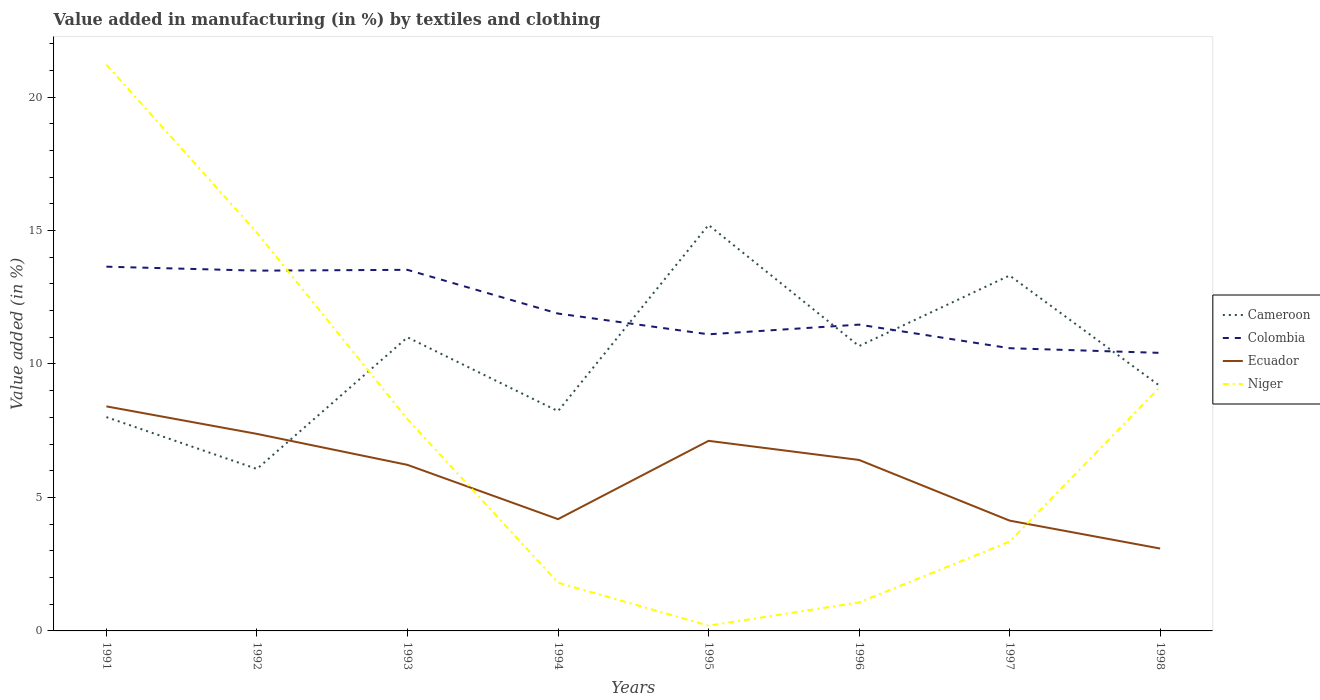How many different coloured lines are there?
Your answer should be compact. 4. Does the line corresponding to Colombia intersect with the line corresponding to Ecuador?
Offer a very short reply. No. Is the number of lines equal to the number of legend labels?
Make the answer very short. Yes. Across all years, what is the maximum percentage of value added in manufacturing by textiles and clothing in Colombia?
Offer a very short reply. 10.42. In which year was the percentage of value added in manufacturing by textiles and clothing in Cameroon maximum?
Offer a terse response. 1992. What is the total percentage of value added in manufacturing by textiles and clothing in Ecuador in the graph?
Your response must be concise. 2.01. What is the difference between the highest and the second highest percentage of value added in manufacturing by textiles and clothing in Ecuador?
Give a very brief answer. 5.33. Is the percentage of value added in manufacturing by textiles and clothing in Cameroon strictly greater than the percentage of value added in manufacturing by textiles and clothing in Niger over the years?
Make the answer very short. No. How many lines are there?
Ensure brevity in your answer.  4. How many years are there in the graph?
Your answer should be very brief. 8. Where does the legend appear in the graph?
Offer a terse response. Center right. What is the title of the graph?
Your response must be concise. Value added in manufacturing (in %) by textiles and clothing. What is the label or title of the Y-axis?
Give a very brief answer. Value added (in %). What is the Value added (in %) in Cameroon in 1991?
Keep it short and to the point. 8.01. What is the Value added (in %) in Colombia in 1991?
Your answer should be compact. 13.64. What is the Value added (in %) of Ecuador in 1991?
Ensure brevity in your answer.  8.41. What is the Value added (in %) in Niger in 1991?
Provide a short and direct response. 21.21. What is the Value added (in %) of Cameroon in 1992?
Offer a very short reply. 6.07. What is the Value added (in %) of Colombia in 1992?
Keep it short and to the point. 13.5. What is the Value added (in %) of Ecuador in 1992?
Offer a terse response. 7.38. What is the Value added (in %) of Niger in 1992?
Provide a succinct answer. 14.92. What is the Value added (in %) of Cameroon in 1993?
Your response must be concise. 11. What is the Value added (in %) in Colombia in 1993?
Your answer should be compact. 13.53. What is the Value added (in %) of Ecuador in 1993?
Your response must be concise. 6.22. What is the Value added (in %) in Niger in 1993?
Provide a succinct answer. 7.93. What is the Value added (in %) in Cameroon in 1994?
Provide a short and direct response. 8.23. What is the Value added (in %) in Colombia in 1994?
Keep it short and to the point. 11.89. What is the Value added (in %) of Ecuador in 1994?
Your response must be concise. 4.19. What is the Value added (in %) of Niger in 1994?
Provide a succinct answer. 1.81. What is the Value added (in %) in Cameroon in 1995?
Give a very brief answer. 15.21. What is the Value added (in %) of Colombia in 1995?
Keep it short and to the point. 11.11. What is the Value added (in %) of Ecuador in 1995?
Give a very brief answer. 7.12. What is the Value added (in %) in Niger in 1995?
Ensure brevity in your answer.  0.2. What is the Value added (in %) of Cameroon in 1996?
Provide a succinct answer. 10.67. What is the Value added (in %) in Colombia in 1996?
Your answer should be compact. 11.47. What is the Value added (in %) of Ecuador in 1996?
Offer a very short reply. 6.4. What is the Value added (in %) in Niger in 1996?
Offer a terse response. 1.07. What is the Value added (in %) of Cameroon in 1997?
Make the answer very short. 13.31. What is the Value added (in %) of Colombia in 1997?
Ensure brevity in your answer.  10.59. What is the Value added (in %) of Ecuador in 1997?
Your answer should be very brief. 4.13. What is the Value added (in %) of Niger in 1997?
Your answer should be very brief. 3.35. What is the Value added (in %) of Cameroon in 1998?
Provide a succinct answer. 9.17. What is the Value added (in %) in Colombia in 1998?
Provide a short and direct response. 10.42. What is the Value added (in %) in Ecuador in 1998?
Ensure brevity in your answer.  3.09. What is the Value added (in %) of Niger in 1998?
Your response must be concise. 9.14. Across all years, what is the maximum Value added (in %) in Cameroon?
Make the answer very short. 15.21. Across all years, what is the maximum Value added (in %) of Colombia?
Your answer should be compact. 13.64. Across all years, what is the maximum Value added (in %) of Ecuador?
Offer a very short reply. 8.41. Across all years, what is the maximum Value added (in %) of Niger?
Give a very brief answer. 21.21. Across all years, what is the minimum Value added (in %) in Cameroon?
Give a very brief answer. 6.07. Across all years, what is the minimum Value added (in %) of Colombia?
Give a very brief answer. 10.42. Across all years, what is the minimum Value added (in %) of Ecuador?
Offer a terse response. 3.09. Across all years, what is the minimum Value added (in %) of Niger?
Keep it short and to the point. 0.2. What is the total Value added (in %) in Cameroon in the graph?
Offer a very short reply. 81.67. What is the total Value added (in %) in Colombia in the graph?
Make the answer very short. 96.15. What is the total Value added (in %) in Ecuador in the graph?
Make the answer very short. 46.94. What is the total Value added (in %) of Niger in the graph?
Ensure brevity in your answer.  59.63. What is the difference between the Value added (in %) of Cameroon in 1991 and that in 1992?
Your response must be concise. 1.94. What is the difference between the Value added (in %) in Colombia in 1991 and that in 1992?
Provide a short and direct response. 0.15. What is the difference between the Value added (in %) in Ecuador in 1991 and that in 1992?
Offer a terse response. 1.03. What is the difference between the Value added (in %) of Niger in 1991 and that in 1992?
Provide a short and direct response. 6.3. What is the difference between the Value added (in %) of Cameroon in 1991 and that in 1993?
Your answer should be very brief. -2.99. What is the difference between the Value added (in %) in Colombia in 1991 and that in 1993?
Offer a very short reply. 0.12. What is the difference between the Value added (in %) of Ecuador in 1991 and that in 1993?
Keep it short and to the point. 2.19. What is the difference between the Value added (in %) in Niger in 1991 and that in 1993?
Make the answer very short. 13.28. What is the difference between the Value added (in %) in Cameroon in 1991 and that in 1994?
Ensure brevity in your answer.  -0.22. What is the difference between the Value added (in %) in Colombia in 1991 and that in 1994?
Make the answer very short. 1.76. What is the difference between the Value added (in %) in Ecuador in 1991 and that in 1994?
Keep it short and to the point. 4.22. What is the difference between the Value added (in %) in Niger in 1991 and that in 1994?
Your response must be concise. 19.4. What is the difference between the Value added (in %) of Cameroon in 1991 and that in 1995?
Make the answer very short. -7.2. What is the difference between the Value added (in %) of Colombia in 1991 and that in 1995?
Ensure brevity in your answer.  2.53. What is the difference between the Value added (in %) of Ecuador in 1991 and that in 1995?
Make the answer very short. 1.29. What is the difference between the Value added (in %) of Niger in 1991 and that in 1995?
Your answer should be compact. 21.02. What is the difference between the Value added (in %) in Cameroon in 1991 and that in 1996?
Provide a succinct answer. -2.66. What is the difference between the Value added (in %) of Colombia in 1991 and that in 1996?
Make the answer very short. 2.17. What is the difference between the Value added (in %) of Ecuador in 1991 and that in 1996?
Keep it short and to the point. 2.01. What is the difference between the Value added (in %) in Niger in 1991 and that in 1996?
Keep it short and to the point. 20.15. What is the difference between the Value added (in %) in Cameroon in 1991 and that in 1997?
Offer a very short reply. -5.3. What is the difference between the Value added (in %) of Colombia in 1991 and that in 1997?
Offer a very short reply. 3.05. What is the difference between the Value added (in %) in Ecuador in 1991 and that in 1997?
Give a very brief answer. 4.28. What is the difference between the Value added (in %) of Niger in 1991 and that in 1997?
Keep it short and to the point. 17.87. What is the difference between the Value added (in %) in Cameroon in 1991 and that in 1998?
Offer a very short reply. -1.16. What is the difference between the Value added (in %) of Colombia in 1991 and that in 1998?
Your answer should be compact. 3.23. What is the difference between the Value added (in %) in Ecuador in 1991 and that in 1998?
Give a very brief answer. 5.33. What is the difference between the Value added (in %) of Niger in 1991 and that in 1998?
Give a very brief answer. 12.07. What is the difference between the Value added (in %) in Cameroon in 1992 and that in 1993?
Ensure brevity in your answer.  -4.93. What is the difference between the Value added (in %) in Colombia in 1992 and that in 1993?
Your answer should be very brief. -0.03. What is the difference between the Value added (in %) of Ecuador in 1992 and that in 1993?
Offer a terse response. 1.16. What is the difference between the Value added (in %) in Niger in 1992 and that in 1993?
Offer a terse response. 6.99. What is the difference between the Value added (in %) of Cameroon in 1992 and that in 1994?
Offer a very short reply. -2.17. What is the difference between the Value added (in %) of Colombia in 1992 and that in 1994?
Your answer should be compact. 1.61. What is the difference between the Value added (in %) of Ecuador in 1992 and that in 1994?
Offer a terse response. 3.19. What is the difference between the Value added (in %) in Niger in 1992 and that in 1994?
Offer a very short reply. 13.11. What is the difference between the Value added (in %) of Cameroon in 1992 and that in 1995?
Provide a short and direct response. -9.14. What is the difference between the Value added (in %) of Colombia in 1992 and that in 1995?
Provide a short and direct response. 2.38. What is the difference between the Value added (in %) of Ecuador in 1992 and that in 1995?
Give a very brief answer. 0.26. What is the difference between the Value added (in %) of Niger in 1992 and that in 1995?
Your answer should be compact. 14.72. What is the difference between the Value added (in %) of Cameroon in 1992 and that in 1996?
Offer a very short reply. -4.6. What is the difference between the Value added (in %) of Colombia in 1992 and that in 1996?
Give a very brief answer. 2.02. What is the difference between the Value added (in %) of Ecuador in 1992 and that in 1996?
Provide a succinct answer. 0.98. What is the difference between the Value added (in %) of Niger in 1992 and that in 1996?
Give a very brief answer. 13.85. What is the difference between the Value added (in %) of Cameroon in 1992 and that in 1997?
Your answer should be very brief. -7.25. What is the difference between the Value added (in %) in Colombia in 1992 and that in 1997?
Ensure brevity in your answer.  2.91. What is the difference between the Value added (in %) in Ecuador in 1992 and that in 1997?
Make the answer very short. 3.25. What is the difference between the Value added (in %) of Niger in 1992 and that in 1997?
Give a very brief answer. 11.57. What is the difference between the Value added (in %) of Cameroon in 1992 and that in 1998?
Ensure brevity in your answer.  -3.1. What is the difference between the Value added (in %) of Colombia in 1992 and that in 1998?
Your answer should be compact. 3.08. What is the difference between the Value added (in %) in Ecuador in 1992 and that in 1998?
Your answer should be compact. 4.29. What is the difference between the Value added (in %) of Niger in 1992 and that in 1998?
Provide a short and direct response. 5.77. What is the difference between the Value added (in %) of Cameroon in 1993 and that in 1994?
Keep it short and to the point. 2.77. What is the difference between the Value added (in %) in Colombia in 1993 and that in 1994?
Your response must be concise. 1.64. What is the difference between the Value added (in %) of Ecuador in 1993 and that in 1994?
Provide a short and direct response. 2.03. What is the difference between the Value added (in %) in Niger in 1993 and that in 1994?
Your answer should be compact. 6.12. What is the difference between the Value added (in %) of Cameroon in 1993 and that in 1995?
Make the answer very short. -4.21. What is the difference between the Value added (in %) in Colombia in 1993 and that in 1995?
Make the answer very short. 2.42. What is the difference between the Value added (in %) of Ecuador in 1993 and that in 1995?
Keep it short and to the point. -0.9. What is the difference between the Value added (in %) of Niger in 1993 and that in 1995?
Keep it short and to the point. 7.73. What is the difference between the Value added (in %) in Cameroon in 1993 and that in 1996?
Offer a terse response. 0.33. What is the difference between the Value added (in %) in Colombia in 1993 and that in 1996?
Give a very brief answer. 2.05. What is the difference between the Value added (in %) in Ecuador in 1993 and that in 1996?
Give a very brief answer. -0.18. What is the difference between the Value added (in %) in Niger in 1993 and that in 1996?
Provide a short and direct response. 6.86. What is the difference between the Value added (in %) of Cameroon in 1993 and that in 1997?
Ensure brevity in your answer.  -2.32. What is the difference between the Value added (in %) in Colombia in 1993 and that in 1997?
Offer a very short reply. 2.94. What is the difference between the Value added (in %) in Ecuador in 1993 and that in 1997?
Offer a terse response. 2.09. What is the difference between the Value added (in %) in Niger in 1993 and that in 1997?
Provide a short and direct response. 4.58. What is the difference between the Value added (in %) in Cameroon in 1993 and that in 1998?
Provide a short and direct response. 1.83. What is the difference between the Value added (in %) of Colombia in 1993 and that in 1998?
Your response must be concise. 3.11. What is the difference between the Value added (in %) in Ecuador in 1993 and that in 1998?
Keep it short and to the point. 3.13. What is the difference between the Value added (in %) of Niger in 1993 and that in 1998?
Keep it short and to the point. -1.21. What is the difference between the Value added (in %) of Cameroon in 1994 and that in 1995?
Offer a terse response. -6.97. What is the difference between the Value added (in %) of Colombia in 1994 and that in 1995?
Your answer should be very brief. 0.78. What is the difference between the Value added (in %) of Ecuador in 1994 and that in 1995?
Provide a succinct answer. -2.93. What is the difference between the Value added (in %) of Niger in 1994 and that in 1995?
Provide a succinct answer. 1.61. What is the difference between the Value added (in %) in Cameroon in 1994 and that in 1996?
Make the answer very short. -2.44. What is the difference between the Value added (in %) of Colombia in 1994 and that in 1996?
Your response must be concise. 0.41. What is the difference between the Value added (in %) of Ecuador in 1994 and that in 1996?
Give a very brief answer. -2.22. What is the difference between the Value added (in %) of Niger in 1994 and that in 1996?
Provide a succinct answer. 0.74. What is the difference between the Value added (in %) in Cameroon in 1994 and that in 1997?
Your answer should be very brief. -5.08. What is the difference between the Value added (in %) of Colombia in 1994 and that in 1997?
Offer a very short reply. 1.3. What is the difference between the Value added (in %) in Ecuador in 1994 and that in 1997?
Keep it short and to the point. 0.06. What is the difference between the Value added (in %) of Niger in 1994 and that in 1997?
Keep it short and to the point. -1.54. What is the difference between the Value added (in %) in Cameroon in 1994 and that in 1998?
Provide a succinct answer. -0.94. What is the difference between the Value added (in %) of Colombia in 1994 and that in 1998?
Your answer should be very brief. 1.47. What is the difference between the Value added (in %) of Ecuador in 1994 and that in 1998?
Keep it short and to the point. 1.1. What is the difference between the Value added (in %) of Niger in 1994 and that in 1998?
Your answer should be compact. -7.33. What is the difference between the Value added (in %) of Cameroon in 1995 and that in 1996?
Provide a succinct answer. 4.54. What is the difference between the Value added (in %) in Colombia in 1995 and that in 1996?
Provide a short and direct response. -0.36. What is the difference between the Value added (in %) in Ecuador in 1995 and that in 1996?
Offer a terse response. 0.72. What is the difference between the Value added (in %) in Niger in 1995 and that in 1996?
Make the answer very short. -0.87. What is the difference between the Value added (in %) of Cameroon in 1995 and that in 1997?
Make the answer very short. 1.89. What is the difference between the Value added (in %) of Colombia in 1995 and that in 1997?
Provide a short and direct response. 0.52. What is the difference between the Value added (in %) of Ecuador in 1995 and that in 1997?
Give a very brief answer. 2.99. What is the difference between the Value added (in %) in Niger in 1995 and that in 1997?
Offer a terse response. -3.15. What is the difference between the Value added (in %) in Cameroon in 1995 and that in 1998?
Your answer should be very brief. 6.04. What is the difference between the Value added (in %) of Colombia in 1995 and that in 1998?
Your response must be concise. 0.7. What is the difference between the Value added (in %) of Ecuador in 1995 and that in 1998?
Your answer should be compact. 4.03. What is the difference between the Value added (in %) of Niger in 1995 and that in 1998?
Your answer should be very brief. -8.95. What is the difference between the Value added (in %) of Cameroon in 1996 and that in 1997?
Provide a succinct answer. -2.64. What is the difference between the Value added (in %) of Colombia in 1996 and that in 1997?
Your answer should be compact. 0.88. What is the difference between the Value added (in %) in Ecuador in 1996 and that in 1997?
Offer a very short reply. 2.27. What is the difference between the Value added (in %) in Niger in 1996 and that in 1997?
Provide a short and direct response. -2.28. What is the difference between the Value added (in %) of Cameroon in 1996 and that in 1998?
Your response must be concise. 1.5. What is the difference between the Value added (in %) of Colombia in 1996 and that in 1998?
Your answer should be compact. 1.06. What is the difference between the Value added (in %) of Ecuador in 1996 and that in 1998?
Your response must be concise. 3.32. What is the difference between the Value added (in %) in Niger in 1996 and that in 1998?
Make the answer very short. -8.08. What is the difference between the Value added (in %) in Cameroon in 1997 and that in 1998?
Ensure brevity in your answer.  4.14. What is the difference between the Value added (in %) of Colombia in 1997 and that in 1998?
Provide a succinct answer. 0.18. What is the difference between the Value added (in %) of Ecuador in 1997 and that in 1998?
Ensure brevity in your answer.  1.05. What is the difference between the Value added (in %) in Niger in 1997 and that in 1998?
Give a very brief answer. -5.8. What is the difference between the Value added (in %) of Cameroon in 1991 and the Value added (in %) of Colombia in 1992?
Provide a short and direct response. -5.49. What is the difference between the Value added (in %) in Cameroon in 1991 and the Value added (in %) in Ecuador in 1992?
Keep it short and to the point. 0.63. What is the difference between the Value added (in %) of Cameroon in 1991 and the Value added (in %) of Niger in 1992?
Provide a succinct answer. -6.91. What is the difference between the Value added (in %) of Colombia in 1991 and the Value added (in %) of Ecuador in 1992?
Your answer should be very brief. 6.26. What is the difference between the Value added (in %) in Colombia in 1991 and the Value added (in %) in Niger in 1992?
Offer a very short reply. -1.27. What is the difference between the Value added (in %) in Ecuador in 1991 and the Value added (in %) in Niger in 1992?
Your answer should be very brief. -6.51. What is the difference between the Value added (in %) of Cameroon in 1991 and the Value added (in %) of Colombia in 1993?
Ensure brevity in your answer.  -5.52. What is the difference between the Value added (in %) of Cameroon in 1991 and the Value added (in %) of Ecuador in 1993?
Your response must be concise. 1.79. What is the difference between the Value added (in %) of Cameroon in 1991 and the Value added (in %) of Niger in 1993?
Give a very brief answer. 0.08. What is the difference between the Value added (in %) in Colombia in 1991 and the Value added (in %) in Ecuador in 1993?
Make the answer very short. 7.42. What is the difference between the Value added (in %) in Colombia in 1991 and the Value added (in %) in Niger in 1993?
Offer a terse response. 5.71. What is the difference between the Value added (in %) in Ecuador in 1991 and the Value added (in %) in Niger in 1993?
Make the answer very short. 0.48. What is the difference between the Value added (in %) in Cameroon in 1991 and the Value added (in %) in Colombia in 1994?
Give a very brief answer. -3.88. What is the difference between the Value added (in %) of Cameroon in 1991 and the Value added (in %) of Ecuador in 1994?
Give a very brief answer. 3.82. What is the difference between the Value added (in %) of Cameroon in 1991 and the Value added (in %) of Niger in 1994?
Offer a very short reply. 6.2. What is the difference between the Value added (in %) in Colombia in 1991 and the Value added (in %) in Ecuador in 1994?
Offer a very short reply. 9.46. What is the difference between the Value added (in %) of Colombia in 1991 and the Value added (in %) of Niger in 1994?
Your answer should be very brief. 11.84. What is the difference between the Value added (in %) in Ecuador in 1991 and the Value added (in %) in Niger in 1994?
Provide a short and direct response. 6.6. What is the difference between the Value added (in %) in Cameroon in 1991 and the Value added (in %) in Colombia in 1995?
Your answer should be very brief. -3.1. What is the difference between the Value added (in %) of Cameroon in 1991 and the Value added (in %) of Ecuador in 1995?
Provide a succinct answer. 0.89. What is the difference between the Value added (in %) in Cameroon in 1991 and the Value added (in %) in Niger in 1995?
Give a very brief answer. 7.81. What is the difference between the Value added (in %) in Colombia in 1991 and the Value added (in %) in Ecuador in 1995?
Offer a terse response. 6.52. What is the difference between the Value added (in %) in Colombia in 1991 and the Value added (in %) in Niger in 1995?
Your response must be concise. 13.45. What is the difference between the Value added (in %) in Ecuador in 1991 and the Value added (in %) in Niger in 1995?
Ensure brevity in your answer.  8.21. What is the difference between the Value added (in %) of Cameroon in 1991 and the Value added (in %) of Colombia in 1996?
Your answer should be compact. -3.46. What is the difference between the Value added (in %) in Cameroon in 1991 and the Value added (in %) in Ecuador in 1996?
Provide a succinct answer. 1.6. What is the difference between the Value added (in %) in Cameroon in 1991 and the Value added (in %) in Niger in 1996?
Your answer should be compact. 6.94. What is the difference between the Value added (in %) of Colombia in 1991 and the Value added (in %) of Ecuador in 1996?
Ensure brevity in your answer.  7.24. What is the difference between the Value added (in %) of Colombia in 1991 and the Value added (in %) of Niger in 1996?
Keep it short and to the point. 12.58. What is the difference between the Value added (in %) of Ecuador in 1991 and the Value added (in %) of Niger in 1996?
Offer a very short reply. 7.34. What is the difference between the Value added (in %) in Cameroon in 1991 and the Value added (in %) in Colombia in 1997?
Your answer should be compact. -2.58. What is the difference between the Value added (in %) of Cameroon in 1991 and the Value added (in %) of Ecuador in 1997?
Provide a short and direct response. 3.88. What is the difference between the Value added (in %) in Cameroon in 1991 and the Value added (in %) in Niger in 1997?
Your answer should be compact. 4.66. What is the difference between the Value added (in %) in Colombia in 1991 and the Value added (in %) in Ecuador in 1997?
Make the answer very short. 9.51. What is the difference between the Value added (in %) in Colombia in 1991 and the Value added (in %) in Niger in 1997?
Make the answer very short. 10.3. What is the difference between the Value added (in %) in Ecuador in 1991 and the Value added (in %) in Niger in 1997?
Give a very brief answer. 5.06. What is the difference between the Value added (in %) of Cameroon in 1991 and the Value added (in %) of Colombia in 1998?
Your answer should be very brief. -2.41. What is the difference between the Value added (in %) in Cameroon in 1991 and the Value added (in %) in Ecuador in 1998?
Give a very brief answer. 4.92. What is the difference between the Value added (in %) of Cameroon in 1991 and the Value added (in %) of Niger in 1998?
Your response must be concise. -1.13. What is the difference between the Value added (in %) in Colombia in 1991 and the Value added (in %) in Ecuador in 1998?
Offer a very short reply. 10.56. What is the difference between the Value added (in %) in Colombia in 1991 and the Value added (in %) in Niger in 1998?
Your answer should be very brief. 4.5. What is the difference between the Value added (in %) of Ecuador in 1991 and the Value added (in %) of Niger in 1998?
Make the answer very short. -0.73. What is the difference between the Value added (in %) of Cameroon in 1992 and the Value added (in %) of Colombia in 1993?
Your response must be concise. -7.46. What is the difference between the Value added (in %) in Cameroon in 1992 and the Value added (in %) in Ecuador in 1993?
Make the answer very short. -0.15. What is the difference between the Value added (in %) in Cameroon in 1992 and the Value added (in %) in Niger in 1993?
Your answer should be compact. -1.86. What is the difference between the Value added (in %) of Colombia in 1992 and the Value added (in %) of Ecuador in 1993?
Offer a terse response. 7.28. What is the difference between the Value added (in %) in Colombia in 1992 and the Value added (in %) in Niger in 1993?
Give a very brief answer. 5.56. What is the difference between the Value added (in %) in Ecuador in 1992 and the Value added (in %) in Niger in 1993?
Provide a succinct answer. -0.55. What is the difference between the Value added (in %) in Cameroon in 1992 and the Value added (in %) in Colombia in 1994?
Ensure brevity in your answer.  -5.82. What is the difference between the Value added (in %) of Cameroon in 1992 and the Value added (in %) of Ecuador in 1994?
Offer a terse response. 1.88. What is the difference between the Value added (in %) of Cameroon in 1992 and the Value added (in %) of Niger in 1994?
Keep it short and to the point. 4.26. What is the difference between the Value added (in %) of Colombia in 1992 and the Value added (in %) of Ecuador in 1994?
Your answer should be very brief. 9.31. What is the difference between the Value added (in %) in Colombia in 1992 and the Value added (in %) in Niger in 1994?
Ensure brevity in your answer.  11.69. What is the difference between the Value added (in %) in Ecuador in 1992 and the Value added (in %) in Niger in 1994?
Offer a terse response. 5.57. What is the difference between the Value added (in %) of Cameroon in 1992 and the Value added (in %) of Colombia in 1995?
Make the answer very short. -5.04. What is the difference between the Value added (in %) of Cameroon in 1992 and the Value added (in %) of Ecuador in 1995?
Your answer should be very brief. -1.05. What is the difference between the Value added (in %) of Cameroon in 1992 and the Value added (in %) of Niger in 1995?
Offer a very short reply. 5.87. What is the difference between the Value added (in %) of Colombia in 1992 and the Value added (in %) of Ecuador in 1995?
Provide a short and direct response. 6.38. What is the difference between the Value added (in %) of Colombia in 1992 and the Value added (in %) of Niger in 1995?
Your answer should be very brief. 13.3. What is the difference between the Value added (in %) of Ecuador in 1992 and the Value added (in %) of Niger in 1995?
Your response must be concise. 7.18. What is the difference between the Value added (in %) in Cameroon in 1992 and the Value added (in %) in Colombia in 1996?
Your answer should be very brief. -5.41. What is the difference between the Value added (in %) in Cameroon in 1992 and the Value added (in %) in Ecuador in 1996?
Your answer should be very brief. -0.34. What is the difference between the Value added (in %) of Cameroon in 1992 and the Value added (in %) of Niger in 1996?
Ensure brevity in your answer.  5. What is the difference between the Value added (in %) in Colombia in 1992 and the Value added (in %) in Ecuador in 1996?
Make the answer very short. 7.09. What is the difference between the Value added (in %) in Colombia in 1992 and the Value added (in %) in Niger in 1996?
Provide a succinct answer. 12.43. What is the difference between the Value added (in %) of Ecuador in 1992 and the Value added (in %) of Niger in 1996?
Ensure brevity in your answer.  6.31. What is the difference between the Value added (in %) in Cameroon in 1992 and the Value added (in %) in Colombia in 1997?
Offer a terse response. -4.52. What is the difference between the Value added (in %) in Cameroon in 1992 and the Value added (in %) in Ecuador in 1997?
Your answer should be very brief. 1.93. What is the difference between the Value added (in %) in Cameroon in 1992 and the Value added (in %) in Niger in 1997?
Offer a terse response. 2.72. What is the difference between the Value added (in %) of Colombia in 1992 and the Value added (in %) of Ecuador in 1997?
Ensure brevity in your answer.  9.36. What is the difference between the Value added (in %) of Colombia in 1992 and the Value added (in %) of Niger in 1997?
Keep it short and to the point. 10.15. What is the difference between the Value added (in %) of Ecuador in 1992 and the Value added (in %) of Niger in 1997?
Provide a succinct answer. 4.03. What is the difference between the Value added (in %) of Cameroon in 1992 and the Value added (in %) of Colombia in 1998?
Ensure brevity in your answer.  -4.35. What is the difference between the Value added (in %) in Cameroon in 1992 and the Value added (in %) in Ecuador in 1998?
Your answer should be compact. 2.98. What is the difference between the Value added (in %) in Cameroon in 1992 and the Value added (in %) in Niger in 1998?
Your answer should be very brief. -3.08. What is the difference between the Value added (in %) of Colombia in 1992 and the Value added (in %) of Ecuador in 1998?
Your answer should be compact. 10.41. What is the difference between the Value added (in %) in Colombia in 1992 and the Value added (in %) in Niger in 1998?
Provide a succinct answer. 4.35. What is the difference between the Value added (in %) in Ecuador in 1992 and the Value added (in %) in Niger in 1998?
Make the answer very short. -1.76. What is the difference between the Value added (in %) of Cameroon in 1993 and the Value added (in %) of Colombia in 1994?
Offer a terse response. -0.89. What is the difference between the Value added (in %) in Cameroon in 1993 and the Value added (in %) in Ecuador in 1994?
Give a very brief answer. 6.81. What is the difference between the Value added (in %) in Cameroon in 1993 and the Value added (in %) in Niger in 1994?
Keep it short and to the point. 9.19. What is the difference between the Value added (in %) of Colombia in 1993 and the Value added (in %) of Ecuador in 1994?
Provide a succinct answer. 9.34. What is the difference between the Value added (in %) of Colombia in 1993 and the Value added (in %) of Niger in 1994?
Keep it short and to the point. 11.72. What is the difference between the Value added (in %) of Ecuador in 1993 and the Value added (in %) of Niger in 1994?
Ensure brevity in your answer.  4.41. What is the difference between the Value added (in %) in Cameroon in 1993 and the Value added (in %) in Colombia in 1995?
Provide a short and direct response. -0.11. What is the difference between the Value added (in %) in Cameroon in 1993 and the Value added (in %) in Ecuador in 1995?
Your response must be concise. 3.88. What is the difference between the Value added (in %) of Cameroon in 1993 and the Value added (in %) of Niger in 1995?
Keep it short and to the point. 10.8. What is the difference between the Value added (in %) of Colombia in 1993 and the Value added (in %) of Ecuador in 1995?
Ensure brevity in your answer.  6.41. What is the difference between the Value added (in %) in Colombia in 1993 and the Value added (in %) in Niger in 1995?
Offer a terse response. 13.33. What is the difference between the Value added (in %) of Ecuador in 1993 and the Value added (in %) of Niger in 1995?
Your response must be concise. 6.02. What is the difference between the Value added (in %) in Cameroon in 1993 and the Value added (in %) in Colombia in 1996?
Give a very brief answer. -0.48. What is the difference between the Value added (in %) in Cameroon in 1993 and the Value added (in %) in Ecuador in 1996?
Make the answer very short. 4.59. What is the difference between the Value added (in %) in Cameroon in 1993 and the Value added (in %) in Niger in 1996?
Give a very brief answer. 9.93. What is the difference between the Value added (in %) in Colombia in 1993 and the Value added (in %) in Ecuador in 1996?
Ensure brevity in your answer.  7.12. What is the difference between the Value added (in %) in Colombia in 1993 and the Value added (in %) in Niger in 1996?
Provide a succinct answer. 12.46. What is the difference between the Value added (in %) in Ecuador in 1993 and the Value added (in %) in Niger in 1996?
Give a very brief answer. 5.15. What is the difference between the Value added (in %) of Cameroon in 1993 and the Value added (in %) of Colombia in 1997?
Keep it short and to the point. 0.41. What is the difference between the Value added (in %) in Cameroon in 1993 and the Value added (in %) in Ecuador in 1997?
Make the answer very short. 6.87. What is the difference between the Value added (in %) of Cameroon in 1993 and the Value added (in %) of Niger in 1997?
Offer a very short reply. 7.65. What is the difference between the Value added (in %) of Colombia in 1993 and the Value added (in %) of Ecuador in 1997?
Provide a short and direct response. 9.39. What is the difference between the Value added (in %) of Colombia in 1993 and the Value added (in %) of Niger in 1997?
Provide a short and direct response. 10.18. What is the difference between the Value added (in %) of Ecuador in 1993 and the Value added (in %) of Niger in 1997?
Your answer should be compact. 2.87. What is the difference between the Value added (in %) in Cameroon in 1993 and the Value added (in %) in Colombia in 1998?
Provide a short and direct response. 0.58. What is the difference between the Value added (in %) of Cameroon in 1993 and the Value added (in %) of Ecuador in 1998?
Your response must be concise. 7.91. What is the difference between the Value added (in %) in Cameroon in 1993 and the Value added (in %) in Niger in 1998?
Keep it short and to the point. 1.85. What is the difference between the Value added (in %) of Colombia in 1993 and the Value added (in %) of Ecuador in 1998?
Ensure brevity in your answer.  10.44. What is the difference between the Value added (in %) of Colombia in 1993 and the Value added (in %) of Niger in 1998?
Keep it short and to the point. 4.38. What is the difference between the Value added (in %) in Ecuador in 1993 and the Value added (in %) in Niger in 1998?
Keep it short and to the point. -2.92. What is the difference between the Value added (in %) in Cameroon in 1994 and the Value added (in %) in Colombia in 1995?
Provide a short and direct response. -2.88. What is the difference between the Value added (in %) of Cameroon in 1994 and the Value added (in %) of Ecuador in 1995?
Make the answer very short. 1.11. What is the difference between the Value added (in %) in Cameroon in 1994 and the Value added (in %) in Niger in 1995?
Provide a succinct answer. 8.03. What is the difference between the Value added (in %) of Colombia in 1994 and the Value added (in %) of Ecuador in 1995?
Offer a very short reply. 4.77. What is the difference between the Value added (in %) of Colombia in 1994 and the Value added (in %) of Niger in 1995?
Your answer should be compact. 11.69. What is the difference between the Value added (in %) in Ecuador in 1994 and the Value added (in %) in Niger in 1995?
Keep it short and to the point. 3.99. What is the difference between the Value added (in %) in Cameroon in 1994 and the Value added (in %) in Colombia in 1996?
Your answer should be very brief. -3.24. What is the difference between the Value added (in %) of Cameroon in 1994 and the Value added (in %) of Ecuador in 1996?
Offer a very short reply. 1.83. What is the difference between the Value added (in %) in Cameroon in 1994 and the Value added (in %) in Niger in 1996?
Your response must be concise. 7.16. What is the difference between the Value added (in %) in Colombia in 1994 and the Value added (in %) in Ecuador in 1996?
Your answer should be very brief. 5.48. What is the difference between the Value added (in %) of Colombia in 1994 and the Value added (in %) of Niger in 1996?
Offer a terse response. 10.82. What is the difference between the Value added (in %) of Ecuador in 1994 and the Value added (in %) of Niger in 1996?
Ensure brevity in your answer.  3.12. What is the difference between the Value added (in %) of Cameroon in 1994 and the Value added (in %) of Colombia in 1997?
Give a very brief answer. -2.36. What is the difference between the Value added (in %) in Cameroon in 1994 and the Value added (in %) in Ecuador in 1997?
Offer a very short reply. 4.1. What is the difference between the Value added (in %) of Cameroon in 1994 and the Value added (in %) of Niger in 1997?
Provide a succinct answer. 4.88. What is the difference between the Value added (in %) in Colombia in 1994 and the Value added (in %) in Ecuador in 1997?
Provide a short and direct response. 7.76. What is the difference between the Value added (in %) of Colombia in 1994 and the Value added (in %) of Niger in 1997?
Ensure brevity in your answer.  8.54. What is the difference between the Value added (in %) in Ecuador in 1994 and the Value added (in %) in Niger in 1997?
Your answer should be very brief. 0.84. What is the difference between the Value added (in %) of Cameroon in 1994 and the Value added (in %) of Colombia in 1998?
Your answer should be very brief. -2.18. What is the difference between the Value added (in %) of Cameroon in 1994 and the Value added (in %) of Ecuador in 1998?
Provide a succinct answer. 5.15. What is the difference between the Value added (in %) of Cameroon in 1994 and the Value added (in %) of Niger in 1998?
Provide a short and direct response. -0.91. What is the difference between the Value added (in %) in Colombia in 1994 and the Value added (in %) in Ecuador in 1998?
Provide a succinct answer. 8.8. What is the difference between the Value added (in %) in Colombia in 1994 and the Value added (in %) in Niger in 1998?
Offer a terse response. 2.74. What is the difference between the Value added (in %) in Ecuador in 1994 and the Value added (in %) in Niger in 1998?
Your answer should be compact. -4.96. What is the difference between the Value added (in %) of Cameroon in 1995 and the Value added (in %) of Colombia in 1996?
Give a very brief answer. 3.73. What is the difference between the Value added (in %) in Cameroon in 1995 and the Value added (in %) in Ecuador in 1996?
Give a very brief answer. 8.8. What is the difference between the Value added (in %) of Cameroon in 1995 and the Value added (in %) of Niger in 1996?
Make the answer very short. 14.14. What is the difference between the Value added (in %) of Colombia in 1995 and the Value added (in %) of Ecuador in 1996?
Ensure brevity in your answer.  4.71. What is the difference between the Value added (in %) in Colombia in 1995 and the Value added (in %) in Niger in 1996?
Offer a very short reply. 10.04. What is the difference between the Value added (in %) in Ecuador in 1995 and the Value added (in %) in Niger in 1996?
Provide a short and direct response. 6.05. What is the difference between the Value added (in %) in Cameroon in 1995 and the Value added (in %) in Colombia in 1997?
Give a very brief answer. 4.62. What is the difference between the Value added (in %) in Cameroon in 1995 and the Value added (in %) in Ecuador in 1997?
Keep it short and to the point. 11.07. What is the difference between the Value added (in %) in Cameroon in 1995 and the Value added (in %) in Niger in 1997?
Make the answer very short. 11.86. What is the difference between the Value added (in %) of Colombia in 1995 and the Value added (in %) of Ecuador in 1997?
Give a very brief answer. 6.98. What is the difference between the Value added (in %) of Colombia in 1995 and the Value added (in %) of Niger in 1997?
Offer a terse response. 7.76. What is the difference between the Value added (in %) of Ecuador in 1995 and the Value added (in %) of Niger in 1997?
Offer a terse response. 3.77. What is the difference between the Value added (in %) of Cameroon in 1995 and the Value added (in %) of Colombia in 1998?
Your answer should be very brief. 4.79. What is the difference between the Value added (in %) in Cameroon in 1995 and the Value added (in %) in Ecuador in 1998?
Offer a very short reply. 12.12. What is the difference between the Value added (in %) in Cameroon in 1995 and the Value added (in %) in Niger in 1998?
Offer a very short reply. 6.06. What is the difference between the Value added (in %) of Colombia in 1995 and the Value added (in %) of Ecuador in 1998?
Your response must be concise. 8.03. What is the difference between the Value added (in %) of Colombia in 1995 and the Value added (in %) of Niger in 1998?
Your answer should be very brief. 1.97. What is the difference between the Value added (in %) in Ecuador in 1995 and the Value added (in %) in Niger in 1998?
Provide a short and direct response. -2.02. What is the difference between the Value added (in %) of Cameroon in 1996 and the Value added (in %) of Colombia in 1997?
Your answer should be very brief. 0.08. What is the difference between the Value added (in %) in Cameroon in 1996 and the Value added (in %) in Ecuador in 1997?
Keep it short and to the point. 6.54. What is the difference between the Value added (in %) in Cameroon in 1996 and the Value added (in %) in Niger in 1997?
Give a very brief answer. 7.32. What is the difference between the Value added (in %) of Colombia in 1996 and the Value added (in %) of Ecuador in 1997?
Give a very brief answer. 7.34. What is the difference between the Value added (in %) in Colombia in 1996 and the Value added (in %) in Niger in 1997?
Provide a short and direct response. 8.13. What is the difference between the Value added (in %) of Ecuador in 1996 and the Value added (in %) of Niger in 1997?
Your answer should be compact. 3.06. What is the difference between the Value added (in %) in Cameroon in 1996 and the Value added (in %) in Colombia in 1998?
Give a very brief answer. 0.25. What is the difference between the Value added (in %) in Cameroon in 1996 and the Value added (in %) in Ecuador in 1998?
Your answer should be very brief. 7.58. What is the difference between the Value added (in %) of Cameroon in 1996 and the Value added (in %) of Niger in 1998?
Provide a succinct answer. 1.53. What is the difference between the Value added (in %) of Colombia in 1996 and the Value added (in %) of Ecuador in 1998?
Offer a terse response. 8.39. What is the difference between the Value added (in %) in Colombia in 1996 and the Value added (in %) in Niger in 1998?
Provide a succinct answer. 2.33. What is the difference between the Value added (in %) in Ecuador in 1996 and the Value added (in %) in Niger in 1998?
Provide a short and direct response. -2.74. What is the difference between the Value added (in %) of Cameroon in 1997 and the Value added (in %) of Colombia in 1998?
Offer a very short reply. 2.9. What is the difference between the Value added (in %) of Cameroon in 1997 and the Value added (in %) of Ecuador in 1998?
Make the answer very short. 10.23. What is the difference between the Value added (in %) of Cameroon in 1997 and the Value added (in %) of Niger in 1998?
Provide a succinct answer. 4.17. What is the difference between the Value added (in %) in Colombia in 1997 and the Value added (in %) in Ecuador in 1998?
Offer a terse response. 7.5. What is the difference between the Value added (in %) of Colombia in 1997 and the Value added (in %) of Niger in 1998?
Offer a very short reply. 1.45. What is the difference between the Value added (in %) in Ecuador in 1997 and the Value added (in %) in Niger in 1998?
Provide a succinct answer. -5.01. What is the average Value added (in %) in Cameroon per year?
Provide a succinct answer. 10.21. What is the average Value added (in %) of Colombia per year?
Provide a succinct answer. 12.02. What is the average Value added (in %) of Ecuador per year?
Offer a very short reply. 5.87. What is the average Value added (in %) in Niger per year?
Keep it short and to the point. 7.45. In the year 1991, what is the difference between the Value added (in %) of Cameroon and Value added (in %) of Colombia?
Provide a short and direct response. -5.63. In the year 1991, what is the difference between the Value added (in %) of Cameroon and Value added (in %) of Ecuador?
Offer a terse response. -0.4. In the year 1991, what is the difference between the Value added (in %) in Cameroon and Value added (in %) in Niger?
Keep it short and to the point. -13.2. In the year 1991, what is the difference between the Value added (in %) of Colombia and Value added (in %) of Ecuador?
Your response must be concise. 5.23. In the year 1991, what is the difference between the Value added (in %) of Colombia and Value added (in %) of Niger?
Your answer should be very brief. -7.57. In the year 1991, what is the difference between the Value added (in %) in Ecuador and Value added (in %) in Niger?
Provide a succinct answer. -12.8. In the year 1992, what is the difference between the Value added (in %) in Cameroon and Value added (in %) in Colombia?
Your answer should be compact. -7.43. In the year 1992, what is the difference between the Value added (in %) in Cameroon and Value added (in %) in Ecuador?
Ensure brevity in your answer.  -1.31. In the year 1992, what is the difference between the Value added (in %) in Cameroon and Value added (in %) in Niger?
Offer a very short reply. -8.85. In the year 1992, what is the difference between the Value added (in %) in Colombia and Value added (in %) in Ecuador?
Your answer should be compact. 6.12. In the year 1992, what is the difference between the Value added (in %) in Colombia and Value added (in %) in Niger?
Offer a very short reply. -1.42. In the year 1992, what is the difference between the Value added (in %) of Ecuador and Value added (in %) of Niger?
Your answer should be very brief. -7.54. In the year 1993, what is the difference between the Value added (in %) in Cameroon and Value added (in %) in Colombia?
Give a very brief answer. -2.53. In the year 1993, what is the difference between the Value added (in %) in Cameroon and Value added (in %) in Ecuador?
Your answer should be compact. 4.78. In the year 1993, what is the difference between the Value added (in %) of Cameroon and Value added (in %) of Niger?
Your answer should be very brief. 3.07. In the year 1993, what is the difference between the Value added (in %) in Colombia and Value added (in %) in Ecuador?
Your answer should be compact. 7.31. In the year 1993, what is the difference between the Value added (in %) of Colombia and Value added (in %) of Niger?
Offer a terse response. 5.6. In the year 1993, what is the difference between the Value added (in %) in Ecuador and Value added (in %) in Niger?
Make the answer very short. -1.71. In the year 1994, what is the difference between the Value added (in %) of Cameroon and Value added (in %) of Colombia?
Keep it short and to the point. -3.66. In the year 1994, what is the difference between the Value added (in %) in Cameroon and Value added (in %) in Ecuador?
Provide a succinct answer. 4.04. In the year 1994, what is the difference between the Value added (in %) of Cameroon and Value added (in %) of Niger?
Give a very brief answer. 6.42. In the year 1994, what is the difference between the Value added (in %) in Colombia and Value added (in %) in Ecuador?
Provide a short and direct response. 7.7. In the year 1994, what is the difference between the Value added (in %) in Colombia and Value added (in %) in Niger?
Your response must be concise. 10.08. In the year 1994, what is the difference between the Value added (in %) of Ecuador and Value added (in %) of Niger?
Your response must be concise. 2.38. In the year 1995, what is the difference between the Value added (in %) in Cameroon and Value added (in %) in Colombia?
Ensure brevity in your answer.  4.1. In the year 1995, what is the difference between the Value added (in %) of Cameroon and Value added (in %) of Ecuador?
Your answer should be very brief. 8.09. In the year 1995, what is the difference between the Value added (in %) in Cameroon and Value added (in %) in Niger?
Make the answer very short. 15.01. In the year 1995, what is the difference between the Value added (in %) of Colombia and Value added (in %) of Ecuador?
Ensure brevity in your answer.  3.99. In the year 1995, what is the difference between the Value added (in %) in Colombia and Value added (in %) in Niger?
Give a very brief answer. 10.91. In the year 1995, what is the difference between the Value added (in %) of Ecuador and Value added (in %) of Niger?
Your answer should be compact. 6.92. In the year 1996, what is the difference between the Value added (in %) in Cameroon and Value added (in %) in Colombia?
Make the answer very short. -0.8. In the year 1996, what is the difference between the Value added (in %) in Cameroon and Value added (in %) in Ecuador?
Offer a very short reply. 4.27. In the year 1996, what is the difference between the Value added (in %) of Cameroon and Value added (in %) of Niger?
Make the answer very short. 9.6. In the year 1996, what is the difference between the Value added (in %) of Colombia and Value added (in %) of Ecuador?
Offer a very short reply. 5.07. In the year 1996, what is the difference between the Value added (in %) in Colombia and Value added (in %) in Niger?
Give a very brief answer. 10.41. In the year 1996, what is the difference between the Value added (in %) in Ecuador and Value added (in %) in Niger?
Give a very brief answer. 5.34. In the year 1997, what is the difference between the Value added (in %) of Cameroon and Value added (in %) of Colombia?
Your answer should be very brief. 2.72. In the year 1997, what is the difference between the Value added (in %) of Cameroon and Value added (in %) of Ecuador?
Make the answer very short. 9.18. In the year 1997, what is the difference between the Value added (in %) of Cameroon and Value added (in %) of Niger?
Offer a very short reply. 9.97. In the year 1997, what is the difference between the Value added (in %) of Colombia and Value added (in %) of Ecuador?
Provide a succinct answer. 6.46. In the year 1997, what is the difference between the Value added (in %) of Colombia and Value added (in %) of Niger?
Your answer should be very brief. 7.24. In the year 1997, what is the difference between the Value added (in %) of Ecuador and Value added (in %) of Niger?
Ensure brevity in your answer.  0.78. In the year 1998, what is the difference between the Value added (in %) in Cameroon and Value added (in %) in Colombia?
Your answer should be very brief. -1.25. In the year 1998, what is the difference between the Value added (in %) in Cameroon and Value added (in %) in Ecuador?
Provide a short and direct response. 6.08. In the year 1998, what is the difference between the Value added (in %) in Cameroon and Value added (in %) in Niger?
Provide a succinct answer. 0.03. In the year 1998, what is the difference between the Value added (in %) in Colombia and Value added (in %) in Ecuador?
Keep it short and to the point. 7.33. In the year 1998, what is the difference between the Value added (in %) in Colombia and Value added (in %) in Niger?
Give a very brief answer. 1.27. In the year 1998, what is the difference between the Value added (in %) in Ecuador and Value added (in %) in Niger?
Give a very brief answer. -6.06. What is the ratio of the Value added (in %) in Cameroon in 1991 to that in 1992?
Your answer should be very brief. 1.32. What is the ratio of the Value added (in %) of Colombia in 1991 to that in 1992?
Make the answer very short. 1.01. What is the ratio of the Value added (in %) in Ecuador in 1991 to that in 1992?
Offer a very short reply. 1.14. What is the ratio of the Value added (in %) in Niger in 1991 to that in 1992?
Give a very brief answer. 1.42. What is the ratio of the Value added (in %) of Cameroon in 1991 to that in 1993?
Your response must be concise. 0.73. What is the ratio of the Value added (in %) of Colombia in 1991 to that in 1993?
Make the answer very short. 1.01. What is the ratio of the Value added (in %) of Ecuador in 1991 to that in 1993?
Give a very brief answer. 1.35. What is the ratio of the Value added (in %) in Niger in 1991 to that in 1993?
Make the answer very short. 2.67. What is the ratio of the Value added (in %) in Colombia in 1991 to that in 1994?
Ensure brevity in your answer.  1.15. What is the ratio of the Value added (in %) of Ecuador in 1991 to that in 1994?
Your answer should be compact. 2.01. What is the ratio of the Value added (in %) of Niger in 1991 to that in 1994?
Provide a short and direct response. 11.73. What is the ratio of the Value added (in %) in Cameroon in 1991 to that in 1995?
Make the answer very short. 0.53. What is the ratio of the Value added (in %) in Colombia in 1991 to that in 1995?
Provide a succinct answer. 1.23. What is the ratio of the Value added (in %) of Ecuador in 1991 to that in 1995?
Offer a terse response. 1.18. What is the ratio of the Value added (in %) of Niger in 1991 to that in 1995?
Offer a terse response. 107.32. What is the ratio of the Value added (in %) of Cameroon in 1991 to that in 1996?
Your answer should be very brief. 0.75. What is the ratio of the Value added (in %) in Colombia in 1991 to that in 1996?
Make the answer very short. 1.19. What is the ratio of the Value added (in %) in Ecuador in 1991 to that in 1996?
Your response must be concise. 1.31. What is the ratio of the Value added (in %) in Niger in 1991 to that in 1996?
Your answer should be compact. 19.86. What is the ratio of the Value added (in %) in Cameroon in 1991 to that in 1997?
Make the answer very short. 0.6. What is the ratio of the Value added (in %) in Colombia in 1991 to that in 1997?
Ensure brevity in your answer.  1.29. What is the ratio of the Value added (in %) of Ecuador in 1991 to that in 1997?
Offer a terse response. 2.04. What is the ratio of the Value added (in %) in Niger in 1991 to that in 1997?
Offer a very short reply. 6.34. What is the ratio of the Value added (in %) of Cameroon in 1991 to that in 1998?
Give a very brief answer. 0.87. What is the ratio of the Value added (in %) of Colombia in 1991 to that in 1998?
Make the answer very short. 1.31. What is the ratio of the Value added (in %) in Ecuador in 1991 to that in 1998?
Make the answer very short. 2.73. What is the ratio of the Value added (in %) of Niger in 1991 to that in 1998?
Provide a succinct answer. 2.32. What is the ratio of the Value added (in %) in Cameroon in 1992 to that in 1993?
Give a very brief answer. 0.55. What is the ratio of the Value added (in %) of Ecuador in 1992 to that in 1993?
Provide a short and direct response. 1.19. What is the ratio of the Value added (in %) of Niger in 1992 to that in 1993?
Offer a terse response. 1.88. What is the ratio of the Value added (in %) in Cameroon in 1992 to that in 1994?
Your answer should be compact. 0.74. What is the ratio of the Value added (in %) in Colombia in 1992 to that in 1994?
Provide a short and direct response. 1.14. What is the ratio of the Value added (in %) of Ecuador in 1992 to that in 1994?
Keep it short and to the point. 1.76. What is the ratio of the Value added (in %) in Niger in 1992 to that in 1994?
Your answer should be very brief. 8.25. What is the ratio of the Value added (in %) in Cameroon in 1992 to that in 1995?
Offer a very short reply. 0.4. What is the ratio of the Value added (in %) of Colombia in 1992 to that in 1995?
Give a very brief answer. 1.21. What is the ratio of the Value added (in %) of Ecuador in 1992 to that in 1995?
Offer a very short reply. 1.04. What is the ratio of the Value added (in %) in Niger in 1992 to that in 1995?
Make the answer very short. 75.47. What is the ratio of the Value added (in %) in Cameroon in 1992 to that in 1996?
Your answer should be very brief. 0.57. What is the ratio of the Value added (in %) in Colombia in 1992 to that in 1996?
Your answer should be very brief. 1.18. What is the ratio of the Value added (in %) of Ecuador in 1992 to that in 1996?
Offer a very short reply. 1.15. What is the ratio of the Value added (in %) in Niger in 1992 to that in 1996?
Provide a succinct answer. 13.97. What is the ratio of the Value added (in %) in Cameroon in 1992 to that in 1997?
Ensure brevity in your answer.  0.46. What is the ratio of the Value added (in %) in Colombia in 1992 to that in 1997?
Provide a short and direct response. 1.27. What is the ratio of the Value added (in %) in Ecuador in 1992 to that in 1997?
Provide a short and direct response. 1.79. What is the ratio of the Value added (in %) of Niger in 1992 to that in 1997?
Your answer should be compact. 4.46. What is the ratio of the Value added (in %) in Cameroon in 1992 to that in 1998?
Provide a succinct answer. 0.66. What is the ratio of the Value added (in %) of Colombia in 1992 to that in 1998?
Offer a terse response. 1.3. What is the ratio of the Value added (in %) of Ecuador in 1992 to that in 1998?
Offer a terse response. 2.39. What is the ratio of the Value added (in %) of Niger in 1992 to that in 1998?
Your response must be concise. 1.63. What is the ratio of the Value added (in %) of Cameroon in 1993 to that in 1994?
Your answer should be very brief. 1.34. What is the ratio of the Value added (in %) in Colombia in 1993 to that in 1994?
Your answer should be compact. 1.14. What is the ratio of the Value added (in %) of Ecuador in 1993 to that in 1994?
Ensure brevity in your answer.  1.49. What is the ratio of the Value added (in %) in Niger in 1993 to that in 1994?
Your answer should be very brief. 4.38. What is the ratio of the Value added (in %) of Cameroon in 1993 to that in 1995?
Your answer should be very brief. 0.72. What is the ratio of the Value added (in %) in Colombia in 1993 to that in 1995?
Keep it short and to the point. 1.22. What is the ratio of the Value added (in %) in Ecuador in 1993 to that in 1995?
Offer a terse response. 0.87. What is the ratio of the Value added (in %) in Niger in 1993 to that in 1995?
Keep it short and to the point. 40.12. What is the ratio of the Value added (in %) of Cameroon in 1993 to that in 1996?
Ensure brevity in your answer.  1.03. What is the ratio of the Value added (in %) of Colombia in 1993 to that in 1996?
Your answer should be very brief. 1.18. What is the ratio of the Value added (in %) in Ecuador in 1993 to that in 1996?
Provide a short and direct response. 0.97. What is the ratio of the Value added (in %) in Niger in 1993 to that in 1996?
Your response must be concise. 7.43. What is the ratio of the Value added (in %) in Cameroon in 1993 to that in 1997?
Offer a terse response. 0.83. What is the ratio of the Value added (in %) of Colombia in 1993 to that in 1997?
Give a very brief answer. 1.28. What is the ratio of the Value added (in %) in Ecuador in 1993 to that in 1997?
Offer a terse response. 1.51. What is the ratio of the Value added (in %) of Niger in 1993 to that in 1997?
Ensure brevity in your answer.  2.37. What is the ratio of the Value added (in %) in Cameroon in 1993 to that in 1998?
Your response must be concise. 1.2. What is the ratio of the Value added (in %) in Colombia in 1993 to that in 1998?
Provide a short and direct response. 1.3. What is the ratio of the Value added (in %) of Ecuador in 1993 to that in 1998?
Ensure brevity in your answer.  2.02. What is the ratio of the Value added (in %) in Niger in 1993 to that in 1998?
Keep it short and to the point. 0.87. What is the ratio of the Value added (in %) of Cameroon in 1994 to that in 1995?
Offer a very short reply. 0.54. What is the ratio of the Value added (in %) in Colombia in 1994 to that in 1995?
Your answer should be very brief. 1.07. What is the ratio of the Value added (in %) in Ecuador in 1994 to that in 1995?
Provide a short and direct response. 0.59. What is the ratio of the Value added (in %) of Niger in 1994 to that in 1995?
Offer a terse response. 9.15. What is the ratio of the Value added (in %) in Cameroon in 1994 to that in 1996?
Keep it short and to the point. 0.77. What is the ratio of the Value added (in %) in Colombia in 1994 to that in 1996?
Provide a short and direct response. 1.04. What is the ratio of the Value added (in %) in Ecuador in 1994 to that in 1996?
Keep it short and to the point. 0.65. What is the ratio of the Value added (in %) in Niger in 1994 to that in 1996?
Give a very brief answer. 1.69. What is the ratio of the Value added (in %) in Cameroon in 1994 to that in 1997?
Give a very brief answer. 0.62. What is the ratio of the Value added (in %) in Colombia in 1994 to that in 1997?
Provide a succinct answer. 1.12. What is the ratio of the Value added (in %) in Ecuador in 1994 to that in 1997?
Your response must be concise. 1.01. What is the ratio of the Value added (in %) of Niger in 1994 to that in 1997?
Give a very brief answer. 0.54. What is the ratio of the Value added (in %) of Cameroon in 1994 to that in 1998?
Offer a very short reply. 0.9. What is the ratio of the Value added (in %) of Colombia in 1994 to that in 1998?
Your answer should be very brief. 1.14. What is the ratio of the Value added (in %) of Ecuador in 1994 to that in 1998?
Make the answer very short. 1.36. What is the ratio of the Value added (in %) in Niger in 1994 to that in 1998?
Provide a succinct answer. 0.2. What is the ratio of the Value added (in %) in Cameroon in 1995 to that in 1996?
Your answer should be compact. 1.43. What is the ratio of the Value added (in %) of Colombia in 1995 to that in 1996?
Keep it short and to the point. 0.97. What is the ratio of the Value added (in %) in Ecuador in 1995 to that in 1996?
Your response must be concise. 1.11. What is the ratio of the Value added (in %) of Niger in 1995 to that in 1996?
Give a very brief answer. 0.19. What is the ratio of the Value added (in %) in Cameroon in 1995 to that in 1997?
Offer a terse response. 1.14. What is the ratio of the Value added (in %) in Colombia in 1995 to that in 1997?
Your answer should be very brief. 1.05. What is the ratio of the Value added (in %) of Ecuador in 1995 to that in 1997?
Make the answer very short. 1.72. What is the ratio of the Value added (in %) of Niger in 1995 to that in 1997?
Keep it short and to the point. 0.06. What is the ratio of the Value added (in %) of Cameroon in 1995 to that in 1998?
Offer a very short reply. 1.66. What is the ratio of the Value added (in %) of Colombia in 1995 to that in 1998?
Provide a short and direct response. 1.07. What is the ratio of the Value added (in %) of Ecuador in 1995 to that in 1998?
Keep it short and to the point. 2.31. What is the ratio of the Value added (in %) in Niger in 1995 to that in 1998?
Give a very brief answer. 0.02. What is the ratio of the Value added (in %) in Cameroon in 1996 to that in 1997?
Keep it short and to the point. 0.8. What is the ratio of the Value added (in %) of Colombia in 1996 to that in 1997?
Your answer should be very brief. 1.08. What is the ratio of the Value added (in %) of Ecuador in 1996 to that in 1997?
Provide a succinct answer. 1.55. What is the ratio of the Value added (in %) in Niger in 1996 to that in 1997?
Provide a short and direct response. 0.32. What is the ratio of the Value added (in %) in Cameroon in 1996 to that in 1998?
Provide a succinct answer. 1.16. What is the ratio of the Value added (in %) of Colombia in 1996 to that in 1998?
Your answer should be very brief. 1.1. What is the ratio of the Value added (in %) of Ecuador in 1996 to that in 1998?
Offer a terse response. 2.08. What is the ratio of the Value added (in %) in Niger in 1996 to that in 1998?
Keep it short and to the point. 0.12. What is the ratio of the Value added (in %) in Cameroon in 1997 to that in 1998?
Your answer should be compact. 1.45. What is the ratio of the Value added (in %) of Colombia in 1997 to that in 1998?
Give a very brief answer. 1.02. What is the ratio of the Value added (in %) in Ecuador in 1997 to that in 1998?
Keep it short and to the point. 1.34. What is the ratio of the Value added (in %) of Niger in 1997 to that in 1998?
Provide a short and direct response. 0.37. What is the difference between the highest and the second highest Value added (in %) of Cameroon?
Offer a terse response. 1.89. What is the difference between the highest and the second highest Value added (in %) in Colombia?
Provide a succinct answer. 0.12. What is the difference between the highest and the second highest Value added (in %) of Ecuador?
Keep it short and to the point. 1.03. What is the difference between the highest and the second highest Value added (in %) in Niger?
Give a very brief answer. 6.3. What is the difference between the highest and the lowest Value added (in %) in Cameroon?
Offer a very short reply. 9.14. What is the difference between the highest and the lowest Value added (in %) of Colombia?
Your response must be concise. 3.23. What is the difference between the highest and the lowest Value added (in %) of Ecuador?
Offer a very short reply. 5.33. What is the difference between the highest and the lowest Value added (in %) in Niger?
Provide a succinct answer. 21.02. 